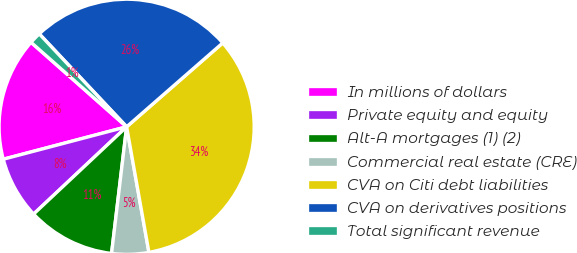<chart> <loc_0><loc_0><loc_500><loc_500><pie_chart><fcel>In millions of dollars<fcel>Private equity and equity<fcel>Alt-A mortgages (1) (2)<fcel>Commercial real estate (CRE)<fcel>CVA on Citi debt liabilities<fcel>CVA on derivatives positions<fcel>Total significant revenue<nl><fcel>15.61%<fcel>7.9%<fcel>11.12%<fcel>4.68%<fcel>33.62%<fcel>25.59%<fcel>1.47%<nl></chart> 